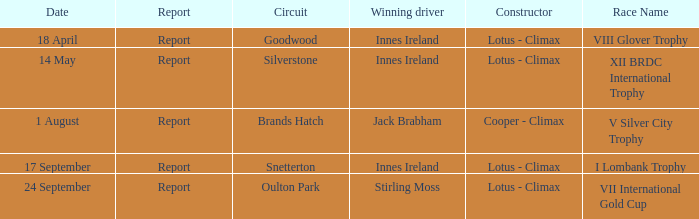What is the name of the race where Stirling Moss was the winning driver? VII International Gold Cup. 